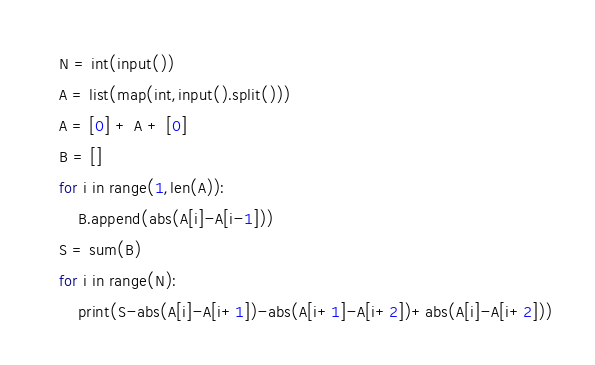Convert code to text. <code><loc_0><loc_0><loc_500><loc_500><_Python_>N = int(input())
A = list(map(int,input().split()))
A = [0] + A + [0]
B = []
for i in range(1,len(A)):
    B.append(abs(A[i]-A[i-1]))
S = sum(B)
for i in range(N):
    print(S-abs(A[i]-A[i+1])-abs(A[i+1]-A[i+2])+abs(A[i]-A[i+2]))
</code> 